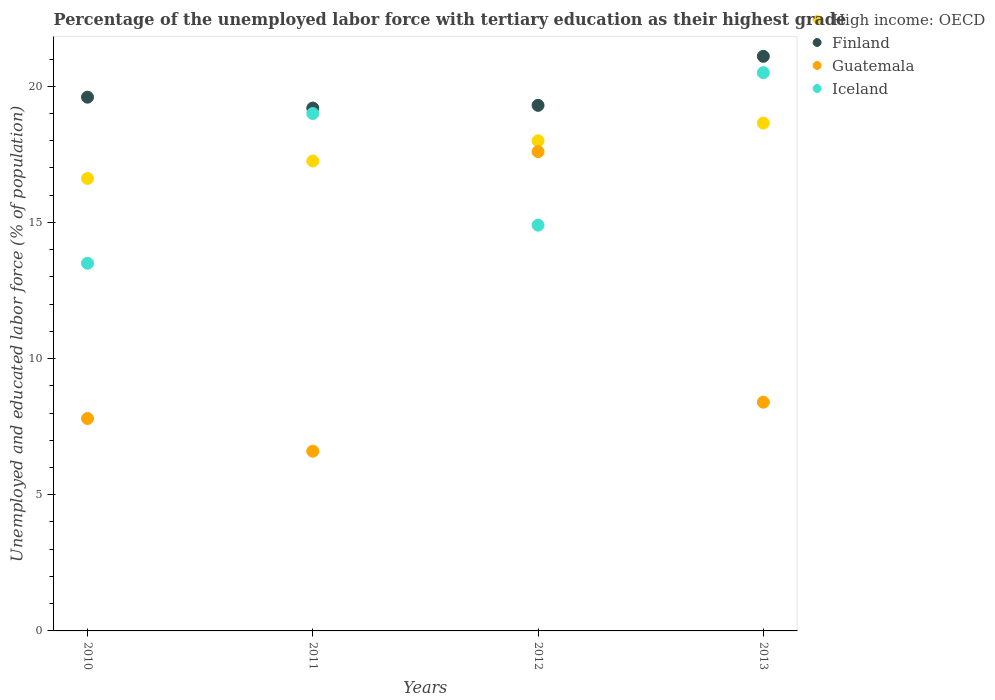How many different coloured dotlines are there?
Offer a terse response. 4. What is the percentage of the unemployed labor force with tertiary education in Iceland in 2011?
Make the answer very short. 19. Across all years, what is the maximum percentage of the unemployed labor force with tertiary education in High income: OECD?
Keep it short and to the point. 18.65. Across all years, what is the minimum percentage of the unemployed labor force with tertiary education in High income: OECD?
Provide a short and direct response. 16.62. In which year was the percentage of the unemployed labor force with tertiary education in Iceland maximum?
Offer a terse response. 2013. In which year was the percentage of the unemployed labor force with tertiary education in Iceland minimum?
Ensure brevity in your answer.  2010. What is the total percentage of the unemployed labor force with tertiary education in Iceland in the graph?
Keep it short and to the point. 67.9. What is the difference between the percentage of the unemployed labor force with tertiary education in Iceland in 2010 and that in 2012?
Offer a terse response. -1.4. What is the difference between the percentage of the unemployed labor force with tertiary education in Iceland in 2012 and the percentage of the unemployed labor force with tertiary education in Guatemala in 2010?
Ensure brevity in your answer.  7.1. What is the average percentage of the unemployed labor force with tertiary education in High income: OECD per year?
Provide a short and direct response. 17.63. In the year 2010, what is the difference between the percentage of the unemployed labor force with tertiary education in High income: OECD and percentage of the unemployed labor force with tertiary education in Finland?
Keep it short and to the point. -2.98. In how many years, is the percentage of the unemployed labor force with tertiary education in Guatemala greater than 7 %?
Give a very brief answer. 3. What is the ratio of the percentage of the unemployed labor force with tertiary education in Iceland in 2010 to that in 2012?
Your answer should be compact. 0.91. Is the percentage of the unemployed labor force with tertiary education in Guatemala in 2010 less than that in 2012?
Your response must be concise. Yes. Is the difference between the percentage of the unemployed labor force with tertiary education in High income: OECD in 2010 and 2013 greater than the difference between the percentage of the unemployed labor force with tertiary education in Finland in 2010 and 2013?
Give a very brief answer. No. Is the sum of the percentage of the unemployed labor force with tertiary education in Iceland in 2010 and 2012 greater than the maximum percentage of the unemployed labor force with tertiary education in High income: OECD across all years?
Give a very brief answer. Yes. Is the percentage of the unemployed labor force with tertiary education in Guatemala strictly greater than the percentage of the unemployed labor force with tertiary education in High income: OECD over the years?
Provide a succinct answer. No. Is the percentage of the unemployed labor force with tertiary education in High income: OECD strictly less than the percentage of the unemployed labor force with tertiary education in Iceland over the years?
Keep it short and to the point. No. How many dotlines are there?
Your answer should be compact. 4. How many years are there in the graph?
Make the answer very short. 4. What is the difference between two consecutive major ticks on the Y-axis?
Your answer should be very brief. 5. Where does the legend appear in the graph?
Keep it short and to the point. Top right. How many legend labels are there?
Provide a short and direct response. 4. How are the legend labels stacked?
Ensure brevity in your answer.  Vertical. What is the title of the graph?
Provide a succinct answer. Percentage of the unemployed labor force with tertiary education as their highest grade. Does "Turkmenistan" appear as one of the legend labels in the graph?
Keep it short and to the point. No. What is the label or title of the X-axis?
Your answer should be compact. Years. What is the label or title of the Y-axis?
Provide a short and direct response. Unemployed and educated labor force (% of population). What is the Unemployed and educated labor force (% of population) of High income: OECD in 2010?
Offer a very short reply. 16.62. What is the Unemployed and educated labor force (% of population) in Finland in 2010?
Offer a terse response. 19.6. What is the Unemployed and educated labor force (% of population) of Guatemala in 2010?
Your answer should be compact. 7.8. What is the Unemployed and educated labor force (% of population) of Iceland in 2010?
Give a very brief answer. 13.5. What is the Unemployed and educated labor force (% of population) of High income: OECD in 2011?
Offer a terse response. 17.26. What is the Unemployed and educated labor force (% of population) of Finland in 2011?
Make the answer very short. 19.2. What is the Unemployed and educated labor force (% of population) of Guatemala in 2011?
Offer a very short reply. 6.6. What is the Unemployed and educated labor force (% of population) in Iceland in 2011?
Ensure brevity in your answer.  19. What is the Unemployed and educated labor force (% of population) in High income: OECD in 2012?
Your answer should be compact. 18. What is the Unemployed and educated labor force (% of population) of Finland in 2012?
Give a very brief answer. 19.3. What is the Unemployed and educated labor force (% of population) of Guatemala in 2012?
Make the answer very short. 17.6. What is the Unemployed and educated labor force (% of population) of Iceland in 2012?
Your response must be concise. 14.9. What is the Unemployed and educated labor force (% of population) of High income: OECD in 2013?
Keep it short and to the point. 18.65. What is the Unemployed and educated labor force (% of population) of Finland in 2013?
Keep it short and to the point. 21.1. What is the Unemployed and educated labor force (% of population) in Guatemala in 2013?
Offer a terse response. 8.4. What is the Unemployed and educated labor force (% of population) in Iceland in 2013?
Your answer should be very brief. 20.5. Across all years, what is the maximum Unemployed and educated labor force (% of population) in High income: OECD?
Provide a short and direct response. 18.65. Across all years, what is the maximum Unemployed and educated labor force (% of population) in Finland?
Ensure brevity in your answer.  21.1. Across all years, what is the maximum Unemployed and educated labor force (% of population) of Guatemala?
Offer a terse response. 17.6. Across all years, what is the maximum Unemployed and educated labor force (% of population) of Iceland?
Offer a very short reply. 20.5. Across all years, what is the minimum Unemployed and educated labor force (% of population) of High income: OECD?
Provide a short and direct response. 16.62. Across all years, what is the minimum Unemployed and educated labor force (% of population) in Finland?
Your answer should be very brief. 19.2. Across all years, what is the minimum Unemployed and educated labor force (% of population) in Guatemala?
Ensure brevity in your answer.  6.6. What is the total Unemployed and educated labor force (% of population) in High income: OECD in the graph?
Ensure brevity in your answer.  70.52. What is the total Unemployed and educated labor force (% of population) of Finland in the graph?
Give a very brief answer. 79.2. What is the total Unemployed and educated labor force (% of population) of Guatemala in the graph?
Give a very brief answer. 40.4. What is the total Unemployed and educated labor force (% of population) in Iceland in the graph?
Give a very brief answer. 67.9. What is the difference between the Unemployed and educated labor force (% of population) of High income: OECD in 2010 and that in 2011?
Your response must be concise. -0.64. What is the difference between the Unemployed and educated labor force (% of population) in Guatemala in 2010 and that in 2011?
Keep it short and to the point. 1.2. What is the difference between the Unemployed and educated labor force (% of population) of High income: OECD in 2010 and that in 2012?
Provide a succinct answer. -1.38. What is the difference between the Unemployed and educated labor force (% of population) of Iceland in 2010 and that in 2012?
Your answer should be compact. -1.4. What is the difference between the Unemployed and educated labor force (% of population) in High income: OECD in 2010 and that in 2013?
Offer a very short reply. -2.03. What is the difference between the Unemployed and educated labor force (% of population) of Guatemala in 2010 and that in 2013?
Your answer should be very brief. -0.6. What is the difference between the Unemployed and educated labor force (% of population) in High income: OECD in 2011 and that in 2012?
Keep it short and to the point. -0.74. What is the difference between the Unemployed and educated labor force (% of population) in Finland in 2011 and that in 2012?
Make the answer very short. -0.1. What is the difference between the Unemployed and educated labor force (% of population) of Guatemala in 2011 and that in 2012?
Provide a succinct answer. -11. What is the difference between the Unemployed and educated labor force (% of population) of Iceland in 2011 and that in 2012?
Offer a terse response. 4.1. What is the difference between the Unemployed and educated labor force (% of population) in High income: OECD in 2011 and that in 2013?
Your answer should be compact. -1.39. What is the difference between the Unemployed and educated labor force (% of population) in High income: OECD in 2012 and that in 2013?
Keep it short and to the point. -0.65. What is the difference between the Unemployed and educated labor force (% of population) of Iceland in 2012 and that in 2013?
Offer a very short reply. -5.6. What is the difference between the Unemployed and educated labor force (% of population) of High income: OECD in 2010 and the Unemployed and educated labor force (% of population) of Finland in 2011?
Your answer should be compact. -2.58. What is the difference between the Unemployed and educated labor force (% of population) in High income: OECD in 2010 and the Unemployed and educated labor force (% of population) in Guatemala in 2011?
Ensure brevity in your answer.  10.02. What is the difference between the Unemployed and educated labor force (% of population) in High income: OECD in 2010 and the Unemployed and educated labor force (% of population) in Iceland in 2011?
Your response must be concise. -2.38. What is the difference between the Unemployed and educated labor force (% of population) of Finland in 2010 and the Unemployed and educated labor force (% of population) of Guatemala in 2011?
Offer a terse response. 13. What is the difference between the Unemployed and educated labor force (% of population) in Guatemala in 2010 and the Unemployed and educated labor force (% of population) in Iceland in 2011?
Make the answer very short. -11.2. What is the difference between the Unemployed and educated labor force (% of population) in High income: OECD in 2010 and the Unemployed and educated labor force (% of population) in Finland in 2012?
Keep it short and to the point. -2.68. What is the difference between the Unemployed and educated labor force (% of population) in High income: OECD in 2010 and the Unemployed and educated labor force (% of population) in Guatemala in 2012?
Your answer should be compact. -0.98. What is the difference between the Unemployed and educated labor force (% of population) of High income: OECD in 2010 and the Unemployed and educated labor force (% of population) of Iceland in 2012?
Your answer should be compact. 1.72. What is the difference between the Unemployed and educated labor force (% of population) in Guatemala in 2010 and the Unemployed and educated labor force (% of population) in Iceland in 2012?
Make the answer very short. -7.1. What is the difference between the Unemployed and educated labor force (% of population) in High income: OECD in 2010 and the Unemployed and educated labor force (% of population) in Finland in 2013?
Provide a succinct answer. -4.48. What is the difference between the Unemployed and educated labor force (% of population) of High income: OECD in 2010 and the Unemployed and educated labor force (% of population) of Guatemala in 2013?
Give a very brief answer. 8.22. What is the difference between the Unemployed and educated labor force (% of population) of High income: OECD in 2010 and the Unemployed and educated labor force (% of population) of Iceland in 2013?
Make the answer very short. -3.88. What is the difference between the Unemployed and educated labor force (% of population) of Finland in 2010 and the Unemployed and educated labor force (% of population) of Iceland in 2013?
Your response must be concise. -0.9. What is the difference between the Unemployed and educated labor force (% of population) of High income: OECD in 2011 and the Unemployed and educated labor force (% of population) of Finland in 2012?
Offer a very short reply. -2.04. What is the difference between the Unemployed and educated labor force (% of population) of High income: OECD in 2011 and the Unemployed and educated labor force (% of population) of Guatemala in 2012?
Ensure brevity in your answer.  -0.34. What is the difference between the Unemployed and educated labor force (% of population) of High income: OECD in 2011 and the Unemployed and educated labor force (% of population) of Iceland in 2012?
Provide a succinct answer. 2.36. What is the difference between the Unemployed and educated labor force (% of population) of Finland in 2011 and the Unemployed and educated labor force (% of population) of Guatemala in 2012?
Provide a succinct answer. 1.6. What is the difference between the Unemployed and educated labor force (% of population) in Finland in 2011 and the Unemployed and educated labor force (% of population) in Iceland in 2012?
Provide a succinct answer. 4.3. What is the difference between the Unemployed and educated labor force (% of population) in Guatemala in 2011 and the Unemployed and educated labor force (% of population) in Iceland in 2012?
Your answer should be very brief. -8.3. What is the difference between the Unemployed and educated labor force (% of population) in High income: OECD in 2011 and the Unemployed and educated labor force (% of population) in Finland in 2013?
Ensure brevity in your answer.  -3.84. What is the difference between the Unemployed and educated labor force (% of population) in High income: OECD in 2011 and the Unemployed and educated labor force (% of population) in Guatemala in 2013?
Your response must be concise. 8.86. What is the difference between the Unemployed and educated labor force (% of population) in High income: OECD in 2011 and the Unemployed and educated labor force (% of population) in Iceland in 2013?
Your answer should be very brief. -3.24. What is the difference between the Unemployed and educated labor force (% of population) in Finland in 2011 and the Unemployed and educated labor force (% of population) in Iceland in 2013?
Offer a terse response. -1.3. What is the difference between the Unemployed and educated labor force (% of population) of Guatemala in 2011 and the Unemployed and educated labor force (% of population) of Iceland in 2013?
Make the answer very short. -13.9. What is the difference between the Unemployed and educated labor force (% of population) of High income: OECD in 2012 and the Unemployed and educated labor force (% of population) of Finland in 2013?
Give a very brief answer. -3.1. What is the difference between the Unemployed and educated labor force (% of population) in High income: OECD in 2012 and the Unemployed and educated labor force (% of population) in Guatemala in 2013?
Offer a very short reply. 9.6. What is the difference between the Unemployed and educated labor force (% of population) of High income: OECD in 2012 and the Unemployed and educated labor force (% of population) of Iceland in 2013?
Provide a succinct answer. -2.5. What is the difference between the Unemployed and educated labor force (% of population) of Finland in 2012 and the Unemployed and educated labor force (% of population) of Guatemala in 2013?
Give a very brief answer. 10.9. What is the average Unemployed and educated labor force (% of population) of High income: OECD per year?
Your answer should be very brief. 17.63. What is the average Unemployed and educated labor force (% of population) of Finland per year?
Your answer should be compact. 19.8. What is the average Unemployed and educated labor force (% of population) of Iceland per year?
Make the answer very short. 16.98. In the year 2010, what is the difference between the Unemployed and educated labor force (% of population) in High income: OECD and Unemployed and educated labor force (% of population) in Finland?
Ensure brevity in your answer.  -2.98. In the year 2010, what is the difference between the Unemployed and educated labor force (% of population) of High income: OECD and Unemployed and educated labor force (% of population) of Guatemala?
Your response must be concise. 8.82. In the year 2010, what is the difference between the Unemployed and educated labor force (% of population) of High income: OECD and Unemployed and educated labor force (% of population) of Iceland?
Your answer should be compact. 3.12. In the year 2010, what is the difference between the Unemployed and educated labor force (% of population) of Finland and Unemployed and educated labor force (% of population) of Iceland?
Ensure brevity in your answer.  6.1. In the year 2010, what is the difference between the Unemployed and educated labor force (% of population) of Guatemala and Unemployed and educated labor force (% of population) of Iceland?
Ensure brevity in your answer.  -5.7. In the year 2011, what is the difference between the Unemployed and educated labor force (% of population) in High income: OECD and Unemployed and educated labor force (% of population) in Finland?
Provide a short and direct response. -1.94. In the year 2011, what is the difference between the Unemployed and educated labor force (% of population) in High income: OECD and Unemployed and educated labor force (% of population) in Guatemala?
Provide a succinct answer. 10.66. In the year 2011, what is the difference between the Unemployed and educated labor force (% of population) of High income: OECD and Unemployed and educated labor force (% of population) of Iceland?
Give a very brief answer. -1.74. In the year 2011, what is the difference between the Unemployed and educated labor force (% of population) in Finland and Unemployed and educated labor force (% of population) in Guatemala?
Your answer should be compact. 12.6. In the year 2012, what is the difference between the Unemployed and educated labor force (% of population) of High income: OECD and Unemployed and educated labor force (% of population) of Finland?
Your response must be concise. -1.3. In the year 2012, what is the difference between the Unemployed and educated labor force (% of population) in High income: OECD and Unemployed and educated labor force (% of population) in Guatemala?
Provide a succinct answer. 0.4. In the year 2012, what is the difference between the Unemployed and educated labor force (% of population) in High income: OECD and Unemployed and educated labor force (% of population) in Iceland?
Provide a succinct answer. 3.1. In the year 2012, what is the difference between the Unemployed and educated labor force (% of population) in Finland and Unemployed and educated labor force (% of population) in Guatemala?
Provide a short and direct response. 1.7. In the year 2012, what is the difference between the Unemployed and educated labor force (% of population) in Finland and Unemployed and educated labor force (% of population) in Iceland?
Provide a succinct answer. 4.4. In the year 2013, what is the difference between the Unemployed and educated labor force (% of population) in High income: OECD and Unemployed and educated labor force (% of population) in Finland?
Make the answer very short. -2.45. In the year 2013, what is the difference between the Unemployed and educated labor force (% of population) of High income: OECD and Unemployed and educated labor force (% of population) of Guatemala?
Offer a very short reply. 10.25. In the year 2013, what is the difference between the Unemployed and educated labor force (% of population) of High income: OECD and Unemployed and educated labor force (% of population) of Iceland?
Provide a short and direct response. -1.85. In the year 2013, what is the difference between the Unemployed and educated labor force (% of population) in Finland and Unemployed and educated labor force (% of population) in Iceland?
Your answer should be compact. 0.6. What is the ratio of the Unemployed and educated labor force (% of population) of High income: OECD in 2010 to that in 2011?
Give a very brief answer. 0.96. What is the ratio of the Unemployed and educated labor force (% of population) of Finland in 2010 to that in 2011?
Your answer should be compact. 1.02. What is the ratio of the Unemployed and educated labor force (% of population) of Guatemala in 2010 to that in 2011?
Ensure brevity in your answer.  1.18. What is the ratio of the Unemployed and educated labor force (% of population) in Iceland in 2010 to that in 2011?
Your response must be concise. 0.71. What is the ratio of the Unemployed and educated labor force (% of population) of High income: OECD in 2010 to that in 2012?
Make the answer very short. 0.92. What is the ratio of the Unemployed and educated labor force (% of population) of Finland in 2010 to that in 2012?
Your response must be concise. 1.02. What is the ratio of the Unemployed and educated labor force (% of population) of Guatemala in 2010 to that in 2012?
Ensure brevity in your answer.  0.44. What is the ratio of the Unemployed and educated labor force (% of population) in Iceland in 2010 to that in 2012?
Provide a succinct answer. 0.91. What is the ratio of the Unemployed and educated labor force (% of population) of High income: OECD in 2010 to that in 2013?
Ensure brevity in your answer.  0.89. What is the ratio of the Unemployed and educated labor force (% of population) of Finland in 2010 to that in 2013?
Keep it short and to the point. 0.93. What is the ratio of the Unemployed and educated labor force (% of population) in Guatemala in 2010 to that in 2013?
Offer a very short reply. 0.93. What is the ratio of the Unemployed and educated labor force (% of population) in Iceland in 2010 to that in 2013?
Provide a succinct answer. 0.66. What is the ratio of the Unemployed and educated labor force (% of population) in High income: OECD in 2011 to that in 2012?
Give a very brief answer. 0.96. What is the ratio of the Unemployed and educated labor force (% of population) in Guatemala in 2011 to that in 2012?
Make the answer very short. 0.38. What is the ratio of the Unemployed and educated labor force (% of population) in Iceland in 2011 to that in 2012?
Your answer should be very brief. 1.28. What is the ratio of the Unemployed and educated labor force (% of population) of High income: OECD in 2011 to that in 2013?
Provide a short and direct response. 0.93. What is the ratio of the Unemployed and educated labor force (% of population) of Finland in 2011 to that in 2013?
Offer a very short reply. 0.91. What is the ratio of the Unemployed and educated labor force (% of population) of Guatemala in 2011 to that in 2013?
Your answer should be very brief. 0.79. What is the ratio of the Unemployed and educated labor force (% of population) of Iceland in 2011 to that in 2013?
Make the answer very short. 0.93. What is the ratio of the Unemployed and educated labor force (% of population) of High income: OECD in 2012 to that in 2013?
Make the answer very short. 0.97. What is the ratio of the Unemployed and educated labor force (% of population) in Finland in 2012 to that in 2013?
Offer a terse response. 0.91. What is the ratio of the Unemployed and educated labor force (% of population) of Guatemala in 2012 to that in 2013?
Your response must be concise. 2.1. What is the ratio of the Unemployed and educated labor force (% of population) of Iceland in 2012 to that in 2013?
Make the answer very short. 0.73. What is the difference between the highest and the second highest Unemployed and educated labor force (% of population) in High income: OECD?
Ensure brevity in your answer.  0.65. What is the difference between the highest and the second highest Unemployed and educated labor force (% of population) of Finland?
Provide a short and direct response. 1.5. What is the difference between the highest and the second highest Unemployed and educated labor force (% of population) of Iceland?
Your answer should be very brief. 1.5. What is the difference between the highest and the lowest Unemployed and educated labor force (% of population) in High income: OECD?
Provide a succinct answer. 2.03. What is the difference between the highest and the lowest Unemployed and educated labor force (% of population) of Finland?
Keep it short and to the point. 1.9. What is the difference between the highest and the lowest Unemployed and educated labor force (% of population) in Guatemala?
Keep it short and to the point. 11. What is the difference between the highest and the lowest Unemployed and educated labor force (% of population) in Iceland?
Your response must be concise. 7. 